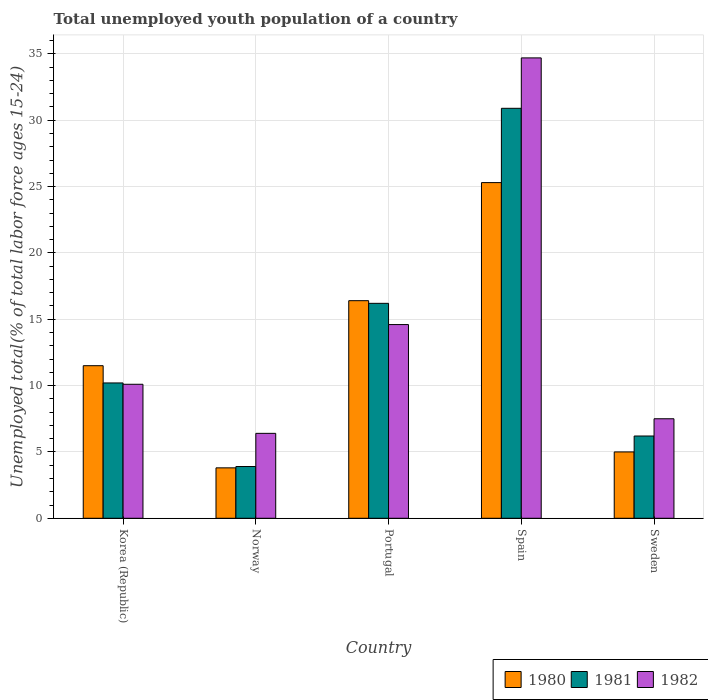Are the number of bars per tick equal to the number of legend labels?
Offer a very short reply. Yes. How many bars are there on the 1st tick from the left?
Offer a terse response. 3. What is the label of the 5th group of bars from the left?
Make the answer very short. Sweden. In how many cases, is the number of bars for a given country not equal to the number of legend labels?
Your answer should be compact. 0. What is the percentage of total unemployed youth population of a country in 1980 in Sweden?
Ensure brevity in your answer.  5. Across all countries, what is the maximum percentage of total unemployed youth population of a country in 1980?
Offer a terse response. 25.3. Across all countries, what is the minimum percentage of total unemployed youth population of a country in 1982?
Ensure brevity in your answer.  6.4. In which country was the percentage of total unemployed youth population of a country in 1980 maximum?
Your answer should be compact. Spain. In which country was the percentage of total unemployed youth population of a country in 1982 minimum?
Provide a succinct answer. Norway. What is the total percentage of total unemployed youth population of a country in 1981 in the graph?
Provide a succinct answer. 67.4. What is the difference between the percentage of total unemployed youth population of a country in 1980 in Korea (Republic) and that in Norway?
Your answer should be very brief. 7.7. What is the difference between the percentage of total unemployed youth population of a country in 1981 in Sweden and the percentage of total unemployed youth population of a country in 1982 in Korea (Republic)?
Offer a terse response. -3.9. What is the average percentage of total unemployed youth population of a country in 1981 per country?
Offer a terse response. 13.48. What is the difference between the percentage of total unemployed youth population of a country of/in 1981 and percentage of total unemployed youth population of a country of/in 1980 in Spain?
Give a very brief answer. 5.6. What is the ratio of the percentage of total unemployed youth population of a country in 1981 in Portugal to that in Spain?
Ensure brevity in your answer.  0.52. Is the percentage of total unemployed youth population of a country in 1981 in Norway less than that in Portugal?
Your answer should be compact. Yes. What is the difference between the highest and the second highest percentage of total unemployed youth population of a country in 1980?
Offer a terse response. -8.9. What is the difference between the highest and the lowest percentage of total unemployed youth population of a country in 1981?
Offer a very short reply. 27. In how many countries, is the percentage of total unemployed youth population of a country in 1981 greater than the average percentage of total unemployed youth population of a country in 1981 taken over all countries?
Make the answer very short. 2. Is it the case that in every country, the sum of the percentage of total unemployed youth population of a country in 1982 and percentage of total unemployed youth population of a country in 1980 is greater than the percentage of total unemployed youth population of a country in 1981?
Your answer should be compact. Yes. How many bars are there?
Offer a terse response. 15. How many countries are there in the graph?
Your answer should be very brief. 5. Does the graph contain grids?
Provide a short and direct response. Yes. Where does the legend appear in the graph?
Provide a succinct answer. Bottom right. What is the title of the graph?
Provide a succinct answer. Total unemployed youth population of a country. What is the label or title of the Y-axis?
Provide a succinct answer. Unemployed total(% of total labor force ages 15-24). What is the Unemployed total(% of total labor force ages 15-24) of 1981 in Korea (Republic)?
Provide a succinct answer. 10.2. What is the Unemployed total(% of total labor force ages 15-24) in 1982 in Korea (Republic)?
Ensure brevity in your answer.  10.1. What is the Unemployed total(% of total labor force ages 15-24) of 1980 in Norway?
Provide a succinct answer. 3.8. What is the Unemployed total(% of total labor force ages 15-24) of 1981 in Norway?
Make the answer very short. 3.9. What is the Unemployed total(% of total labor force ages 15-24) in 1982 in Norway?
Your response must be concise. 6.4. What is the Unemployed total(% of total labor force ages 15-24) of 1980 in Portugal?
Make the answer very short. 16.4. What is the Unemployed total(% of total labor force ages 15-24) of 1981 in Portugal?
Your response must be concise. 16.2. What is the Unemployed total(% of total labor force ages 15-24) of 1982 in Portugal?
Your response must be concise. 14.6. What is the Unemployed total(% of total labor force ages 15-24) of 1980 in Spain?
Provide a succinct answer. 25.3. What is the Unemployed total(% of total labor force ages 15-24) of 1981 in Spain?
Provide a short and direct response. 30.9. What is the Unemployed total(% of total labor force ages 15-24) of 1982 in Spain?
Your answer should be very brief. 34.7. What is the Unemployed total(% of total labor force ages 15-24) in 1980 in Sweden?
Your answer should be compact. 5. What is the Unemployed total(% of total labor force ages 15-24) in 1981 in Sweden?
Ensure brevity in your answer.  6.2. What is the Unemployed total(% of total labor force ages 15-24) in 1982 in Sweden?
Your answer should be compact. 7.5. Across all countries, what is the maximum Unemployed total(% of total labor force ages 15-24) in 1980?
Provide a succinct answer. 25.3. Across all countries, what is the maximum Unemployed total(% of total labor force ages 15-24) in 1981?
Ensure brevity in your answer.  30.9. Across all countries, what is the maximum Unemployed total(% of total labor force ages 15-24) in 1982?
Make the answer very short. 34.7. Across all countries, what is the minimum Unemployed total(% of total labor force ages 15-24) of 1980?
Ensure brevity in your answer.  3.8. Across all countries, what is the minimum Unemployed total(% of total labor force ages 15-24) in 1981?
Give a very brief answer. 3.9. Across all countries, what is the minimum Unemployed total(% of total labor force ages 15-24) in 1982?
Offer a very short reply. 6.4. What is the total Unemployed total(% of total labor force ages 15-24) of 1980 in the graph?
Ensure brevity in your answer.  62. What is the total Unemployed total(% of total labor force ages 15-24) in 1981 in the graph?
Your answer should be very brief. 67.4. What is the total Unemployed total(% of total labor force ages 15-24) in 1982 in the graph?
Give a very brief answer. 73.3. What is the difference between the Unemployed total(% of total labor force ages 15-24) in 1981 in Korea (Republic) and that in Norway?
Offer a very short reply. 6.3. What is the difference between the Unemployed total(% of total labor force ages 15-24) of 1980 in Korea (Republic) and that in Portugal?
Provide a succinct answer. -4.9. What is the difference between the Unemployed total(% of total labor force ages 15-24) of 1980 in Korea (Republic) and that in Spain?
Your answer should be very brief. -13.8. What is the difference between the Unemployed total(% of total labor force ages 15-24) of 1981 in Korea (Republic) and that in Spain?
Offer a very short reply. -20.7. What is the difference between the Unemployed total(% of total labor force ages 15-24) of 1982 in Korea (Republic) and that in Spain?
Ensure brevity in your answer.  -24.6. What is the difference between the Unemployed total(% of total labor force ages 15-24) in 1980 in Korea (Republic) and that in Sweden?
Keep it short and to the point. 6.5. What is the difference between the Unemployed total(% of total labor force ages 15-24) in 1981 in Norway and that in Portugal?
Provide a short and direct response. -12.3. What is the difference between the Unemployed total(% of total labor force ages 15-24) in 1980 in Norway and that in Spain?
Your answer should be very brief. -21.5. What is the difference between the Unemployed total(% of total labor force ages 15-24) in 1981 in Norway and that in Spain?
Keep it short and to the point. -27. What is the difference between the Unemployed total(% of total labor force ages 15-24) of 1982 in Norway and that in Spain?
Give a very brief answer. -28.3. What is the difference between the Unemployed total(% of total labor force ages 15-24) in 1981 in Norway and that in Sweden?
Offer a terse response. -2.3. What is the difference between the Unemployed total(% of total labor force ages 15-24) in 1982 in Norway and that in Sweden?
Keep it short and to the point. -1.1. What is the difference between the Unemployed total(% of total labor force ages 15-24) in 1981 in Portugal and that in Spain?
Give a very brief answer. -14.7. What is the difference between the Unemployed total(% of total labor force ages 15-24) of 1982 in Portugal and that in Spain?
Offer a terse response. -20.1. What is the difference between the Unemployed total(% of total labor force ages 15-24) in 1980 in Portugal and that in Sweden?
Provide a succinct answer. 11.4. What is the difference between the Unemployed total(% of total labor force ages 15-24) in 1980 in Spain and that in Sweden?
Give a very brief answer. 20.3. What is the difference between the Unemployed total(% of total labor force ages 15-24) in 1981 in Spain and that in Sweden?
Ensure brevity in your answer.  24.7. What is the difference between the Unemployed total(% of total labor force ages 15-24) of 1982 in Spain and that in Sweden?
Provide a succinct answer. 27.2. What is the difference between the Unemployed total(% of total labor force ages 15-24) in 1980 in Korea (Republic) and the Unemployed total(% of total labor force ages 15-24) in 1981 in Norway?
Provide a short and direct response. 7.6. What is the difference between the Unemployed total(% of total labor force ages 15-24) of 1980 in Korea (Republic) and the Unemployed total(% of total labor force ages 15-24) of 1982 in Norway?
Make the answer very short. 5.1. What is the difference between the Unemployed total(% of total labor force ages 15-24) in 1981 in Korea (Republic) and the Unemployed total(% of total labor force ages 15-24) in 1982 in Norway?
Ensure brevity in your answer.  3.8. What is the difference between the Unemployed total(% of total labor force ages 15-24) in 1980 in Korea (Republic) and the Unemployed total(% of total labor force ages 15-24) in 1982 in Portugal?
Give a very brief answer. -3.1. What is the difference between the Unemployed total(% of total labor force ages 15-24) in 1980 in Korea (Republic) and the Unemployed total(% of total labor force ages 15-24) in 1981 in Spain?
Your answer should be very brief. -19.4. What is the difference between the Unemployed total(% of total labor force ages 15-24) in 1980 in Korea (Republic) and the Unemployed total(% of total labor force ages 15-24) in 1982 in Spain?
Offer a terse response. -23.2. What is the difference between the Unemployed total(% of total labor force ages 15-24) of 1981 in Korea (Republic) and the Unemployed total(% of total labor force ages 15-24) of 1982 in Spain?
Offer a terse response. -24.5. What is the difference between the Unemployed total(% of total labor force ages 15-24) in 1981 in Korea (Republic) and the Unemployed total(% of total labor force ages 15-24) in 1982 in Sweden?
Give a very brief answer. 2.7. What is the difference between the Unemployed total(% of total labor force ages 15-24) of 1980 in Norway and the Unemployed total(% of total labor force ages 15-24) of 1982 in Portugal?
Give a very brief answer. -10.8. What is the difference between the Unemployed total(% of total labor force ages 15-24) of 1981 in Norway and the Unemployed total(% of total labor force ages 15-24) of 1982 in Portugal?
Provide a short and direct response. -10.7. What is the difference between the Unemployed total(% of total labor force ages 15-24) in 1980 in Norway and the Unemployed total(% of total labor force ages 15-24) in 1981 in Spain?
Your answer should be very brief. -27.1. What is the difference between the Unemployed total(% of total labor force ages 15-24) of 1980 in Norway and the Unemployed total(% of total labor force ages 15-24) of 1982 in Spain?
Offer a terse response. -30.9. What is the difference between the Unemployed total(% of total labor force ages 15-24) of 1981 in Norway and the Unemployed total(% of total labor force ages 15-24) of 1982 in Spain?
Your answer should be very brief. -30.8. What is the difference between the Unemployed total(% of total labor force ages 15-24) in 1980 in Norway and the Unemployed total(% of total labor force ages 15-24) in 1982 in Sweden?
Keep it short and to the point. -3.7. What is the difference between the Unemployed total(% of total labor force ages 15-24) in 1980 in Portugal and the Unemployed total(% of total labor force ages 15-24) in 1981 in Spain?
Your response must be concise. -14.5. What is the difference between the Unemployed total(% of total labor force ages 15-24) of 1980 in Portugal and the Unemployed total(% of total labor force ages 15-24) of 1982 in Spain?
Your response must be concise. -18.3. What is the difference between the Unemployed total(% of total labor force ages 15-24) in 1981 in Portugal and the Unemployed total(% of total labor force ages 15-24) in 1982 in Spain?
Make the answer very short. -18.5. What is the difference between the Unemployed total(% of total labor force ages 15-24) of 1980 in Portugal and the Unemployed total(% of total labor force ages 15-24) of 1981 in Sweden?
Offer a very short reply. 10.2. What is the difference between the Unemployed total(% of total labor force ages 15-24) in 1980 in Portugal and the Unemployed total(% of total labor force ages 15-24) in 1982 in Sweden?
Offer a very short reply. 8.9. What is the difference between the Unemployed total(% of total labor force ages 15-24) in 1980 in Spain and the Unemployed total(% of total labor force ages 15-24) in 1982 in Sweden?
Ensure brevity in your answer.  17.8. What is the difference between the Unemployed total(% of total labor force ages 15-24) in 1981 in Spain and the Unemployed total(% of total labor force ages 15-24) in 1982 in Sweden?
Give a very brief answer. 23.4. What is the average Unemployed total(% of total labor force ages 15-24) in 1981 per country?
Your answer should be compact. 13.48. What is the average Unemployed total(% of total labor force ages 15-24) of 1982 per country?
Your answer should be very brief. 14.66. What is the difference between the Unemployed total(% of total labor force ages 15-24) of 1980 and Unemployed total(% of total labor force ages 15-24) of 1981 in Korea (Republic)?
Offer a very short reply. 1.3. What is the difference between the Unemployed total(% of total labor force ages 15-24) of 1980 and Unemployed total(% of total labor force ages 15-24) of 1981 in Norway?
Keep it short and to the point. -0.1. What is the difference between the Unemployed total(% of total labor force ages 15-24) of 1980 and Unemployed total(% of total labor force ages 15-24) of 1982 in Portugal?
Give a very brief answer. 1.8. What is the difference between the Unemployed total(% of total labor force ages 15-24) in 1980 and Unemployed total(% of total labor force ages 15-24) in 1982 in Spain?
Give a very brief answer. -9.4. What is the difference between the Unemployed total(% of total labor force ages 15-24) of 1980 and Unemployed total(% of total labor force ages 15-24) of 1982 in Sweden?
Keep it short and to the point. -2.5. What is the difference between the Unemployed total(% of total labor force ages 15-24) of 1981 and Unemployed total(% of total labor force ages 15-24) of 1982 in Sweden?
Provide a succinct answer. -1.3. What is the ratio of the Unemployed total(% of total labor force ages 15-24) of 1980 in Korea (Republic) to that in Norway?
Keep it short and to the point. 3.03. What is the ratio of the Unemployed total(% of total labor force ages 15-24) of 1981 in Korea (Republic) to that in Norway?
Your response must be concise. 2.62. What is the ratio of the Unemployed total(% of total labor force ages 15-24) of 1982 in Korea (Republic) to that in Norway?
Your response must be concise. 1.58. What is the ratio of the Unemployed total(% of total labor force ages 15-24) in 1980 in Korea (Republic) to that in Portugal?
Ensure brevity in your answer.  0.7. What is the ratio of the Unemployed total(% of total labor force ages 15-24) of 1981 in Korea (Republic) to that in Portugal?
Give a very brief answer. 0.63. What is the ratio of the Unemployed total(% of total labor force ages 15-24) of 1982 in Korea (Republic) to that in Portugal?
Offer a very short reply. 0.69. What is the ratio of the Unemployed total(% of total labor force ages 15-24) of 1980 in Korea (Republic) to that in Spain?
Your answer should be very brief. 0.45. What is the ratio of the Unemployed total(% of total labor force ages 15-24) of 1981 in Korea (Republic) to that in Spain?
Give a very brief answer. 0.33. What is the ratio of the Unemployed total(% of total labor force ages 15-24) of 1982 in Korea (Republic) to that in Spain?
Your answer should be very brief. 0.29. What is the ratio of the Unemployed total(% of total labor force ages 15-24) in 1981 in Korea (Republic) to that in Sweden?
Make the answer very short. 1.65. What is the ratio of the Unemployed total(% of total labor force ages 15-24) of 1982 in Korea (Republic) to that in Sweden?
Offer a terse response. 1.35. What is the ratio of the Unemployed total(% of total labor force ages 15-24) in 1980 in Norway to that in Portugal?
Keep it short and to the point. 0.23. What is the ratio of the Unemployed total(% of total labor force ages 15-24) of 1981 in Norway to that in Portugal?
Make the answer very short. 0.24. What is the ratio of the Unemployed total(% of total labor force ages 15-24) in 1982 in Norway to that in Portugal?
Provide a short and direct response. 0.44. What is the ratio of the Unemployed total(% of total labor force ages 15-24) in 1980 in Norway to that in Spain?
Ensure brevity in your answer.  0.15. What is the ratio of the Unemployed total(% of total labor force ages 15-24) of 1981 in Norway to that in Spain?
Offer a very short reply. 0.13. What is the ratio of the Unemployed total(% of total labor force ages 15-24) of 1982 in Norway to that in Spain?
Make the answer very short. 0.18. What is the ratio of the Unemployed total(% of total labor force ages 15-24) in 1980 in Norway to that in Sweden?
Ensure brevity in your answer.  0.76. What is the ratio of the Unemployed total(% of total labor force ages 15-24) in 1981 in Norway to that in Sweden?
Keep it short and to the point. 0.63. What is the ratio of the Unemployed total(% of total labor force ages 15-24) of 1982 in Norway to that in Sweden?
Ensure brevity in your answer.  0.85. What is the ratio of the Unemployed total(% of total labor force ages 15-24) of 1980 in Portugal to that in Spain?
Make the answer very short. 0.65. What is the ratio of the Unemployed total(% of total labor force ages 15-24) of 1981 in Portugal to that in Spain?
Make the answer very short. 0.52. What is the ratio of the Unemployed total(% of total labor force ages 15-24) in 1982 in Portugal to that in Spain?
Ensure brevity in your answer.  0.42. What is the ratio of the Unemployed total(% of total labor force ages 15-24) of 1980 in Portugal to that in Sweden?
Provide a succinct answer. 3.28. What is the ratio of the Unemployed total(% of total labor force ages 15-24) of 1981 in Portugal to that in Sweden?
Make the answer very short. 2.61. What is the ratio of the Unemployed total(% of total labor force ages 15-24) of 1982 in Portugal to that in Sweden?
Offer a terse response. 1.95. What is the ratio of the Unemployed total(% of total labor force ages 15-24) of 1980 in Spain to that in Sweden?
Your answer should be very brief. 5.06. What is the ratio of the Unemployed total(% of total labor force ages 15-24) of 1981 in Spain to that in Sweden?
Keep it short and to the point. 4.98. What is the ratio of the Unemployed total(% of total labor force ages 15-24) in 1982 in Spain to that in Sweden?
Give a very brief answer. 4.63. What is the difference between the highest and the second highest Unemployed total(% of total labor force ages 15-24) in 1980?
Give a very brief answer. 8.9. What is the difference between the highest and the second highest Unemployed total(% of total labor force ages 15-24) in 1982?
Offer a terse response. 20.1. What is the difference between the highest and the lowest Unemployed total(% of total labor force ages 15-24) of 1981?
Offer a terse response. 27. What is the difference between the highest and the lowest Unemployed total(% of total labor force ages 15-24) in 1982?
Ensure brevity in your answer.  28.3. 